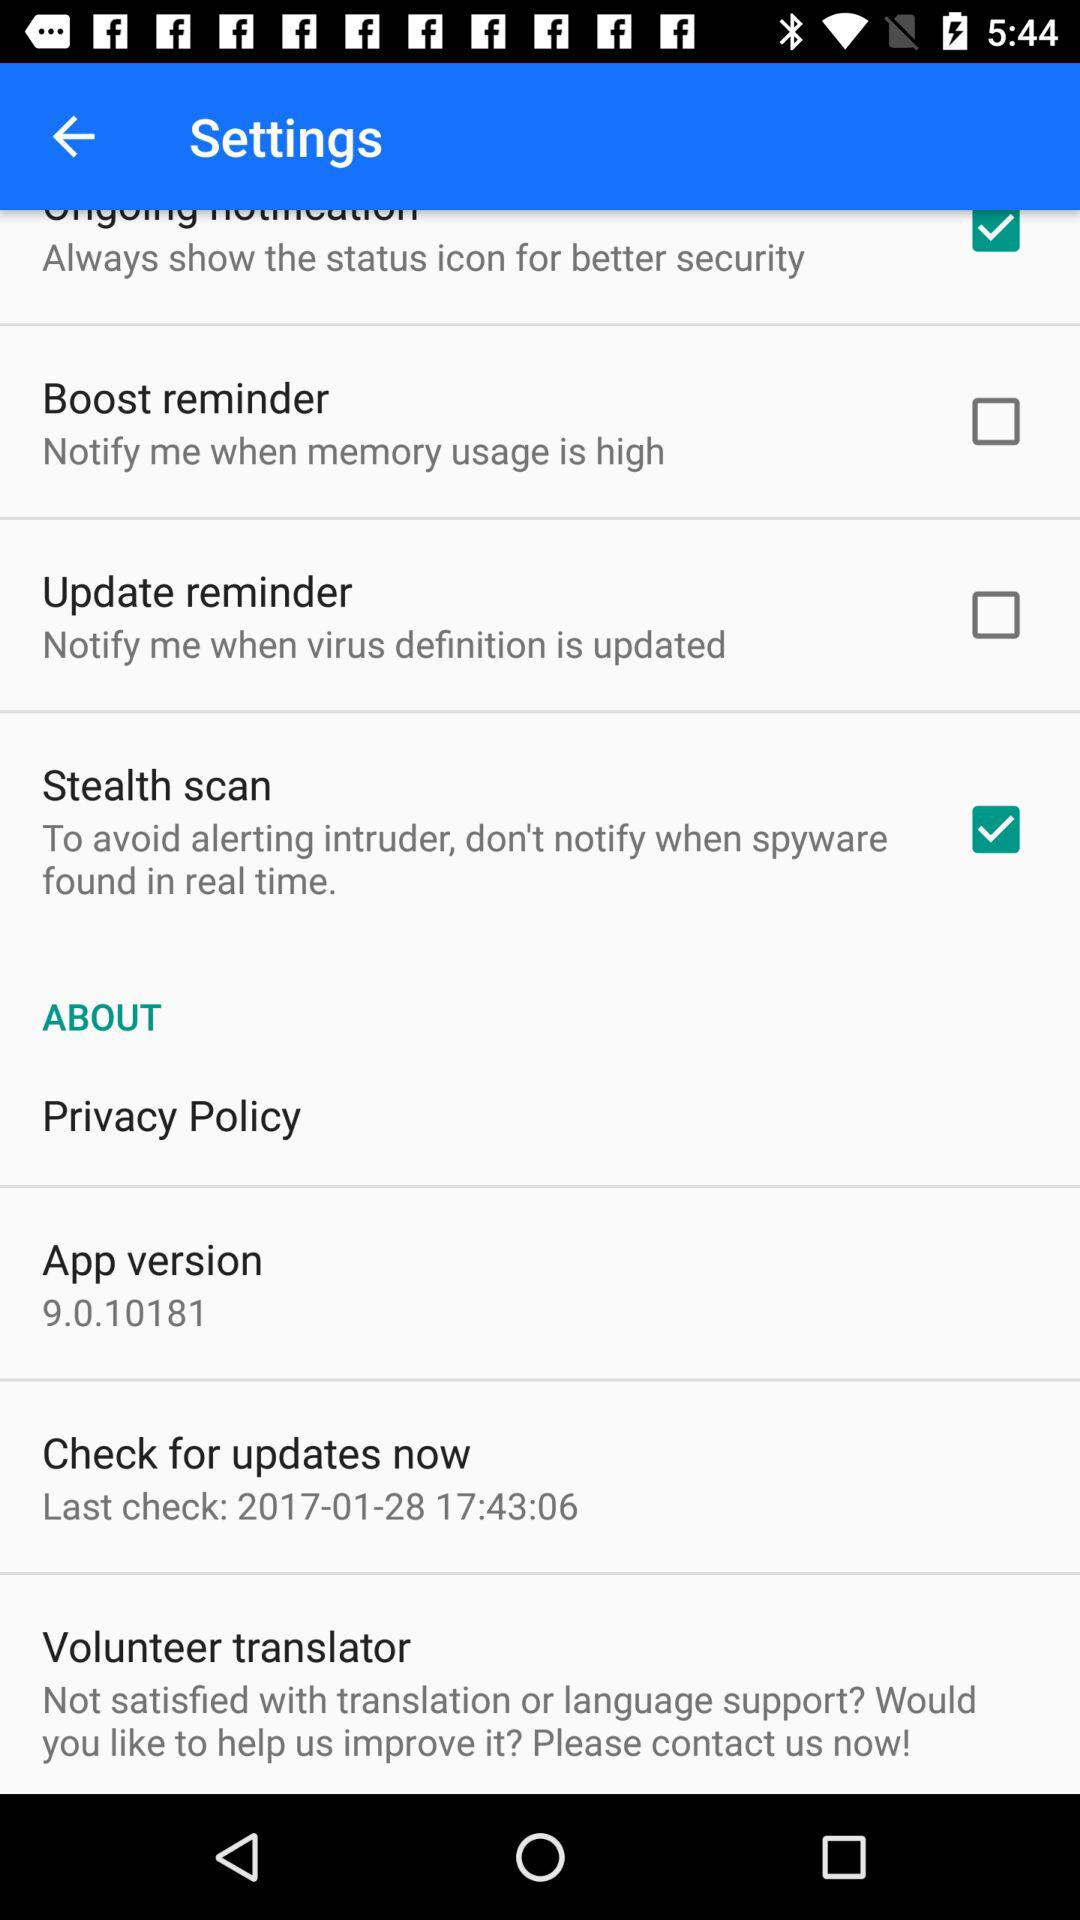What is the setting for the update reminder? The setting for the update setting is "Notify me when virus definition is updated". 